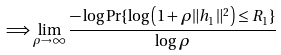Convert formula to latex. <formula><loc_0><loc_0><loc_500><loc_500>\Longrightarrow \lim _ { \rho \rightarrow \infty } \frac { - \log \Pr \{ \log \left ( 1 + \rho \| h _ { 1 } \| ^ { 2 } \right ) \leq R _ { 1 } \} } { \log \rho }</formula> 